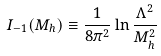<formula> <loc_0><loc_0><loc_500><loc_500>I _ { - 1 } ( M _ { h } ) \equiv \frac { 1 } { 8 \pi ^ { 2 } } \ln { \frac { \Lambda ^ { 2 } } { M _ { h } ^ { 2 } } }</formula> 